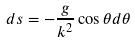<formula> <loc_0><loc_0><loc_500><loc_500>d s = - \frac { g } { k ^ { 2 } } \cos \theta d \theta</formula> 